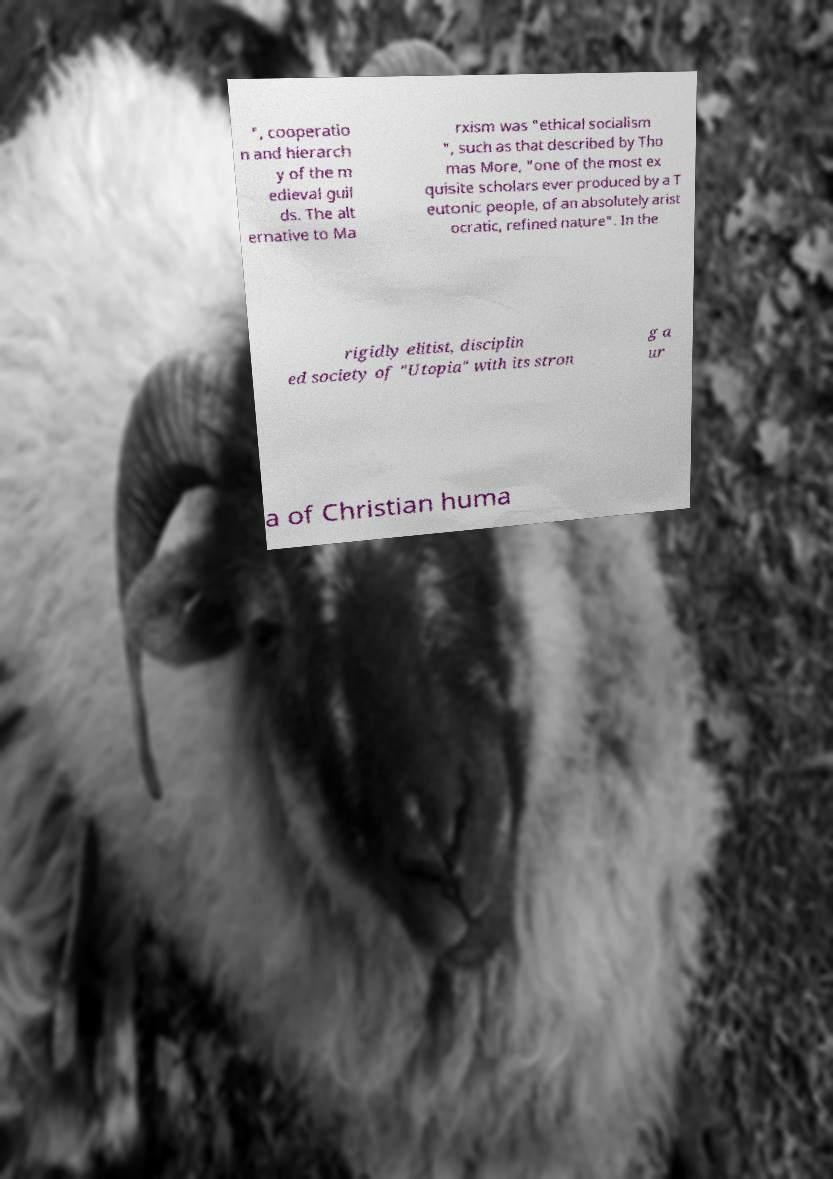Can you accurately transcribe the text from the provided image for me? ", cooperatio n and hierarch y of the m edieval guil ds. The alt ernative to Ma rxism was "ethical socialism ", such as that described by Tho mas More, "one of the most ex quisite scholars ever produced by a T eutonic people, of an absolutely arist ocratic, refined nature". In the rigidly elitist, disciplin ed society of "Utopia" with its stron g a ur a of Christian huma 